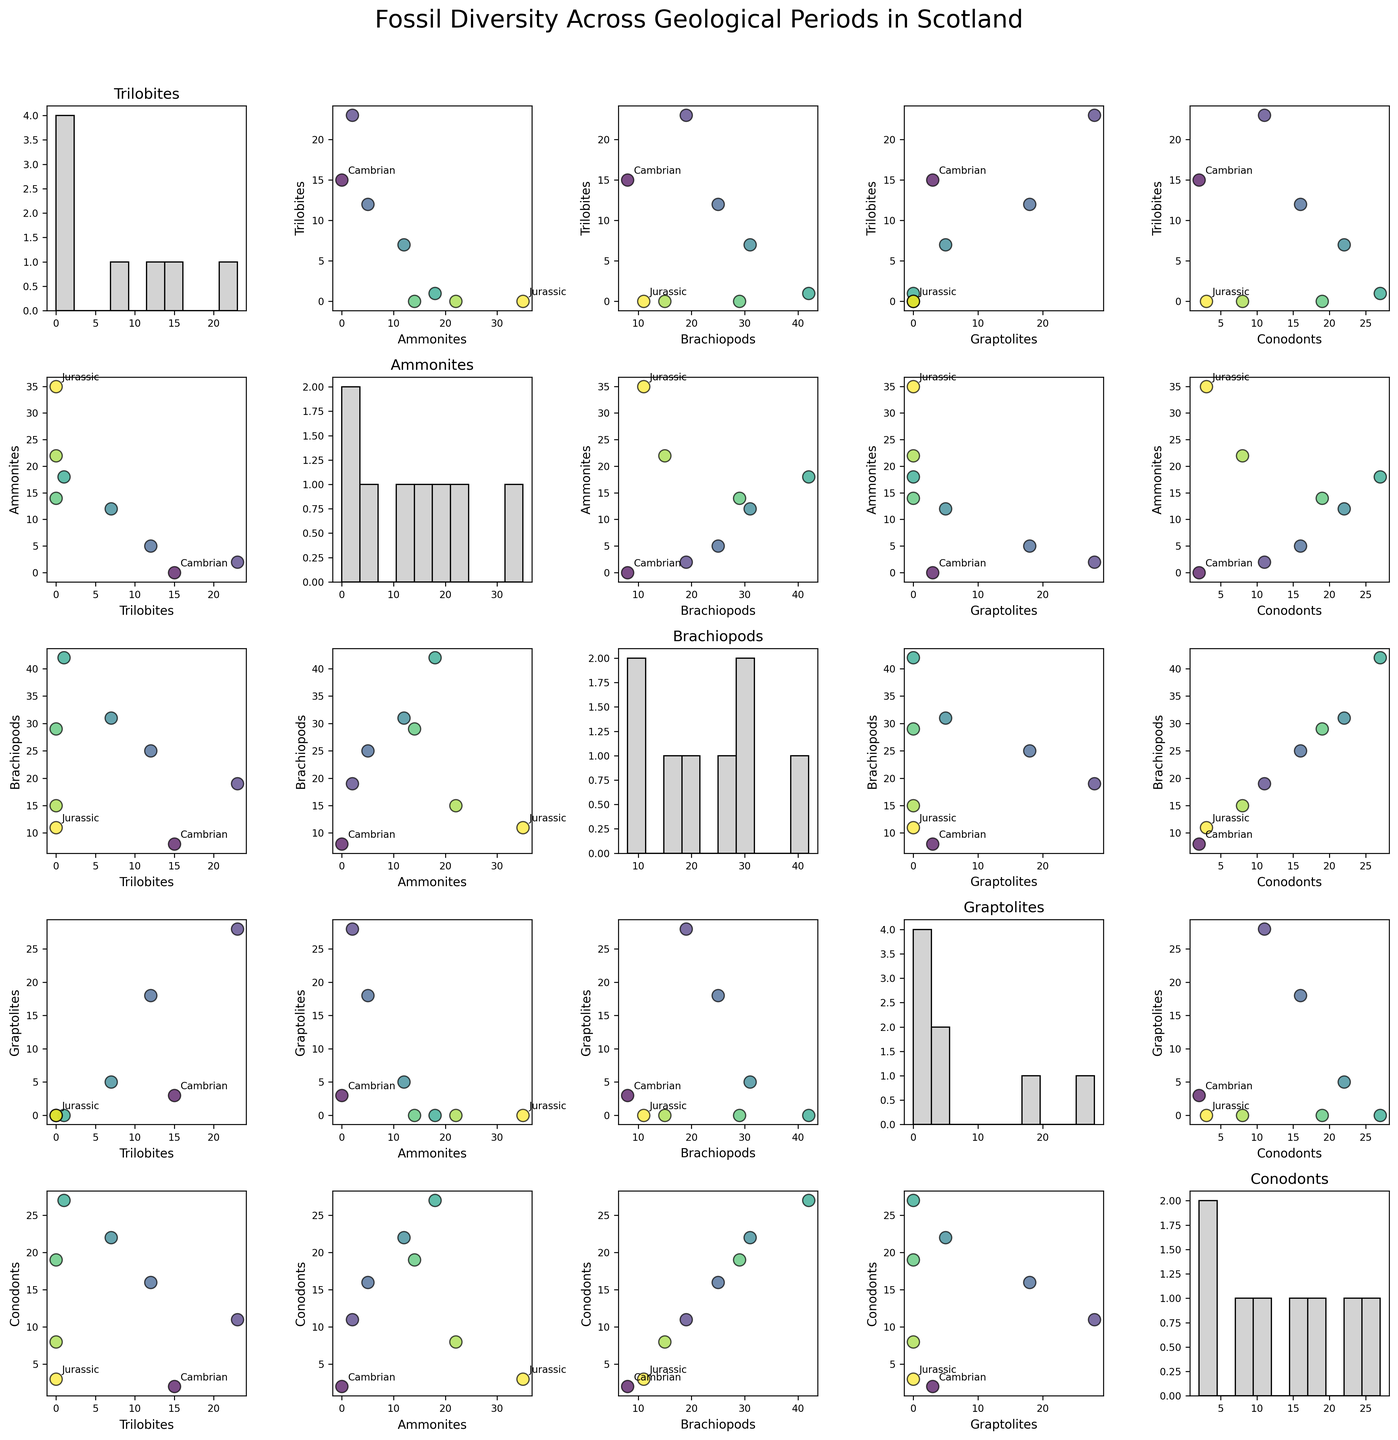How many types of fossils are plotted in the figure? The figure has five types of fossils plotted, which are listed along the axes as Trilobites, Ammonites, Brachiopods, Graptolites, and Conodonts.
Answer: 5 What geological period has the highest diversity of Brachiopods? By examining the scatter plots in the matrix, we find that the Carboniferous period has the highest data point on the Brachiopods axis.
Answer: Carboniferous How do the diversity levels of Ammonites in the Jurassic period compare to those in the Triassic period? By comparing the y-axis values for Ammonites in the scatter plot matrix, it is evident that the Jurassic period shows higher data points for Ammonites than the Triassic period.
Answer: Higher in Jurassic Which geological period had no Trilobites fossil findings in Scotland according to the figure? Trilobites are plotted as zero in the scatter matrix for the Permian, Triassic, and Jurassic periods, reflecting no findings of Trilobites during these periods in Scotland.
Answer: Permian, Triassic, Jurassic On average, how many Ammonite fossils are found across all periods? Sum the Ammonite values across the periods (0 + 2 + 5 + 12 + 18 + 14 + 22 + 35 = 108) and then divide by the number of periods (108 / 8).
Answer: 13.5 How does the diversity of Conodonts in the Carboniferous period compare with that in the Cambrian period? By comparing values for Conodonts in the scatter plot matrix, the Carboniferous period has a higher count of Conodonts (27) than in the Cambrian period (2).
Answer: Higher in Carboniferous Which fossil type has the most even distribution across all periods? By examining the histogram plots on the diagonal, Graptolites and Brachiopods show more even distributions across the periods compared to other fossil types, with less concentration of counts in isolated periods.
Answer: Graptolites, Brachiopods What trend can be observed about the diversity of Brachiopods from the Cambrian to the Carboniferous periods? By noting the positions of Brachiopods data points across the periods from Cambrian to Carboniferous, there's a clear increasing trend in the diversity, peaking in the Carboniferous period.
Answer: Increasing trend Compare the number of Graptolites found in the Silurian period to those found in the Devonian period. Referencing scatter plots, the Silurian period shows more Graptolites (18) compared to the Devonian period (5).
Answer: More in Silurian What can you infer about the diversity co-relationship between Trilobites and Graptolites? Observing scatter plots where Trilobites and Graptolites intersect, there's no clear trend, indicating no significant relationships between their diversities.
Answer: No clear relationship 